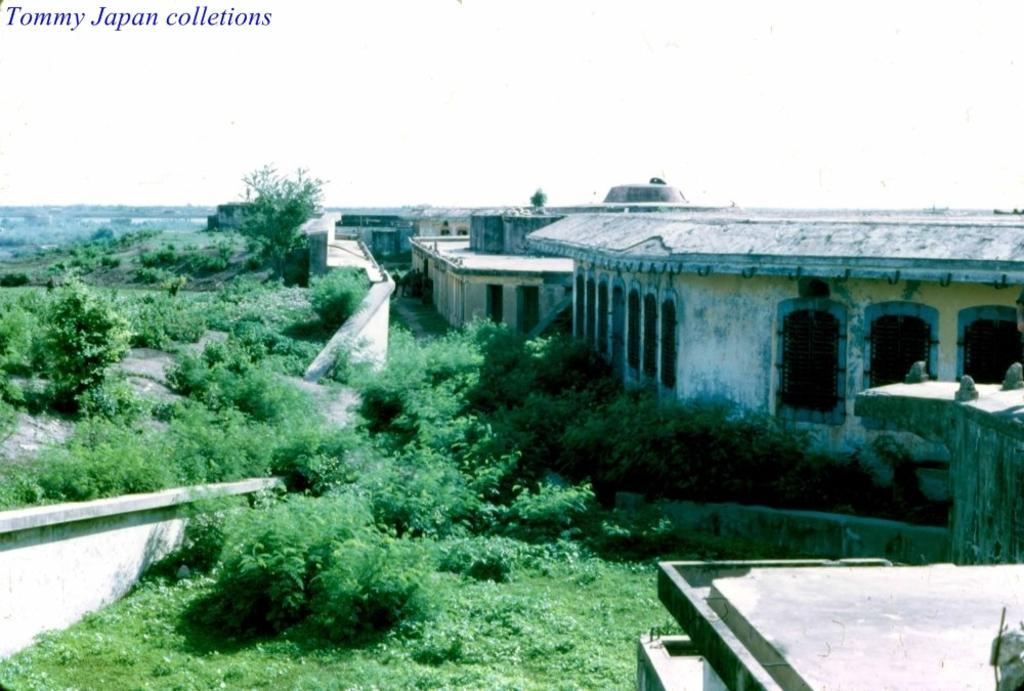In one or two sentences, can you explain what this image depicts? In the center of the image there are houses. There are trees. There is grass. 